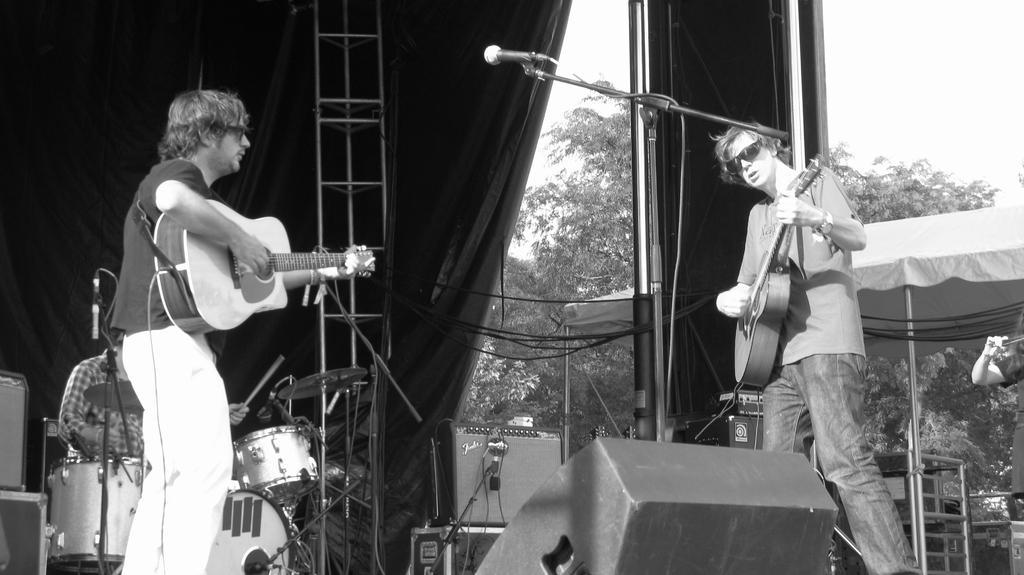How would you summarize this image in a sentence or two? It is a music show the picture looks like a black and white picture there are total three persons first two of them are holding guitars in their hands the person who is standing to the right side is having mike beside him and in the left side there is another person who holding the guitar, behind them there is a person who is sitting and playing the drums and in the background there is a white color curtain and trees and sky. 